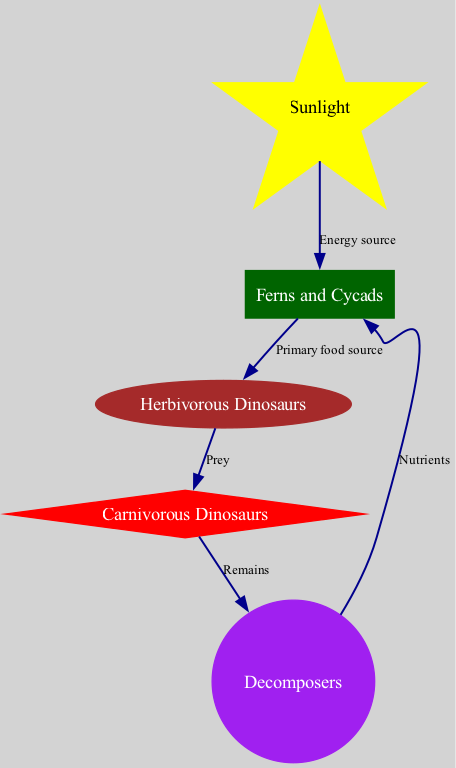What is the first node in the food chain? The first node in the food chain is represented as "Sunlight" in the diagram, indicating it serves as the primary energy source for the ecosystem.
Answer: Sunlight How many total nodes are present in the diagram? The diagram contains five nodes representing components of the food chain: Sunlight, Ferns and Cycads, Herbivorous Dinosaurs, Carnivorous Dinosaurs, and Decomposers.
Answer: Five What do ferns and cycads provide to herbivorous dinosaurs? The diagram states that ferns and cycads serve as the "Primary food source" for herbivorous dinosaurs, indicating their vital role in sustaining this part of the food chain.
Answer: Primary food source How do carnivorous dinosaurs obtain nutrients? According to the diagram, carnivorous dinosaurs receive nutrients through their interaction with decomposers, depicted as "Remains," which are the leftovers after a carnivore has consumed prey.
Answer: Remains What is the relationship type between sunlight and ferns and cycads? The diagram indicates that the relationship between sunlight and ferns and cycads is defined by the label "Energy source," highlighting that sunlight provides necessary energy for the plants' growth.
Answer: Energy source What happens to the remains of carnivorous dinosaurs? In the ecosystem diagram, the remains of carnivorous dinosaurs are processed by decomposers, which return nutrients back into the ecosystem, illustrating their crucial role in nutrient cycling.
Answer: Nutrients How are nutrients returned to ferns and cycads? The diagram illustrates that nutrients from decomposers are cycled back to ferns and cycads, indicating how all elements in the ecosystem are interconnected and rely on one another for sustenance and growth.
Answer: Nutrients What type of organism is directly above decomposers in the diagram? The diagram places ferns and cycads directly above decomposers, indicating that these plants receive the nutrients replenished by the decomposer organisms.
Answer: Ferns and Cycads Which node represents herbivorous dinosaurs? The node representing herbivorous dinosaurs is labeled "Herbivorous Dinosaurs" in the diagram, serving as an essential link between the primary producers and carnivores in the food chain.
Answer: Herbivorous Dinosaurs 